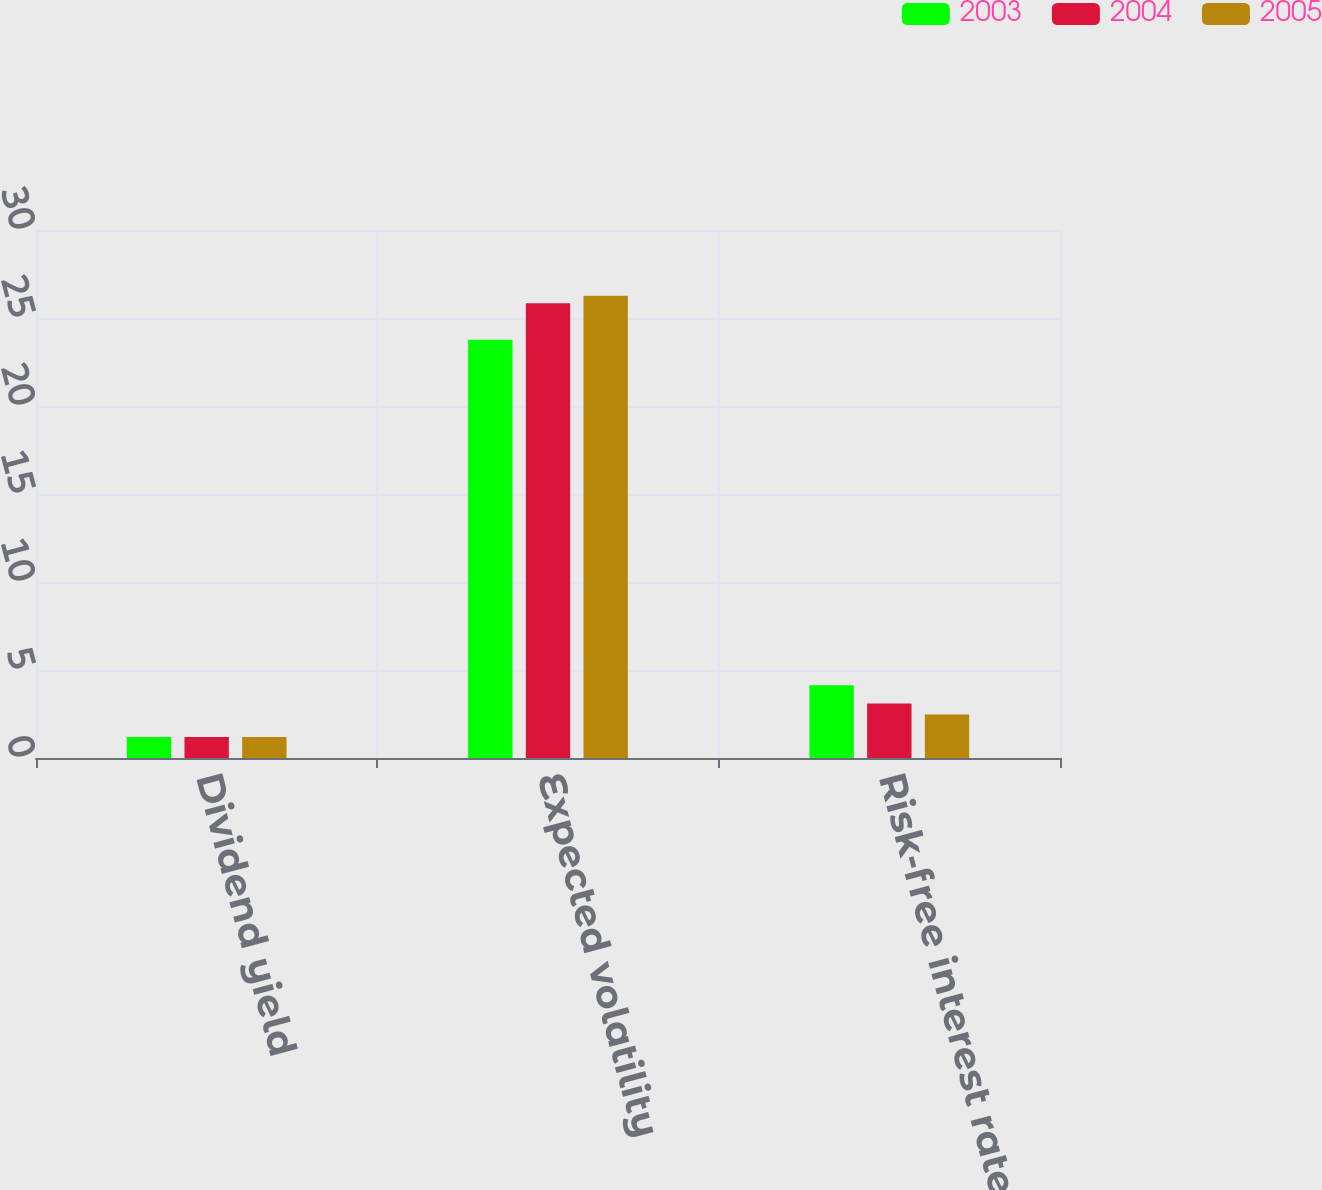<chart> <loc_0><loc_0><loc_500><loc_500><stacked_bar_chart><ecel><fcel>Dividend yield<fcel>Expected volatility<fcel>Risk-free interest rate<nl><fcel>2003<fcel>1.2<fcel>23.77<fcel>4.13<nl><fcel>2004<fcel>1.2<fcel>25.84<fcel>3.1<nl><fcel>2005<fcel>1.2<fcel>26.27<fcel>2.47<nl></chart> 